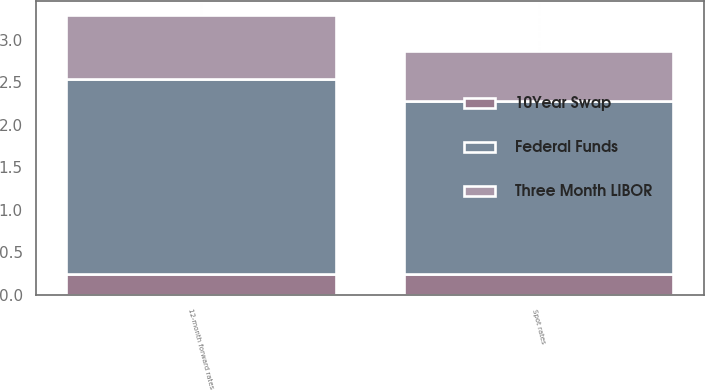Convert chart. <chart><loc_0><loc_0><loc_500><loc_500><stacked_bar_chart><ecel><fcel>Spot rates<fcel>12-month forward rates<nl><fcel>10Year Swap<fcel>0.25<fcel>0.25<nl><fcel>Three Month LIBOR<fcel>0.58<fcel>0.75<nl><fcel>Federal Funds<fcel>2.03<fcel>2.29<nl></chart> 